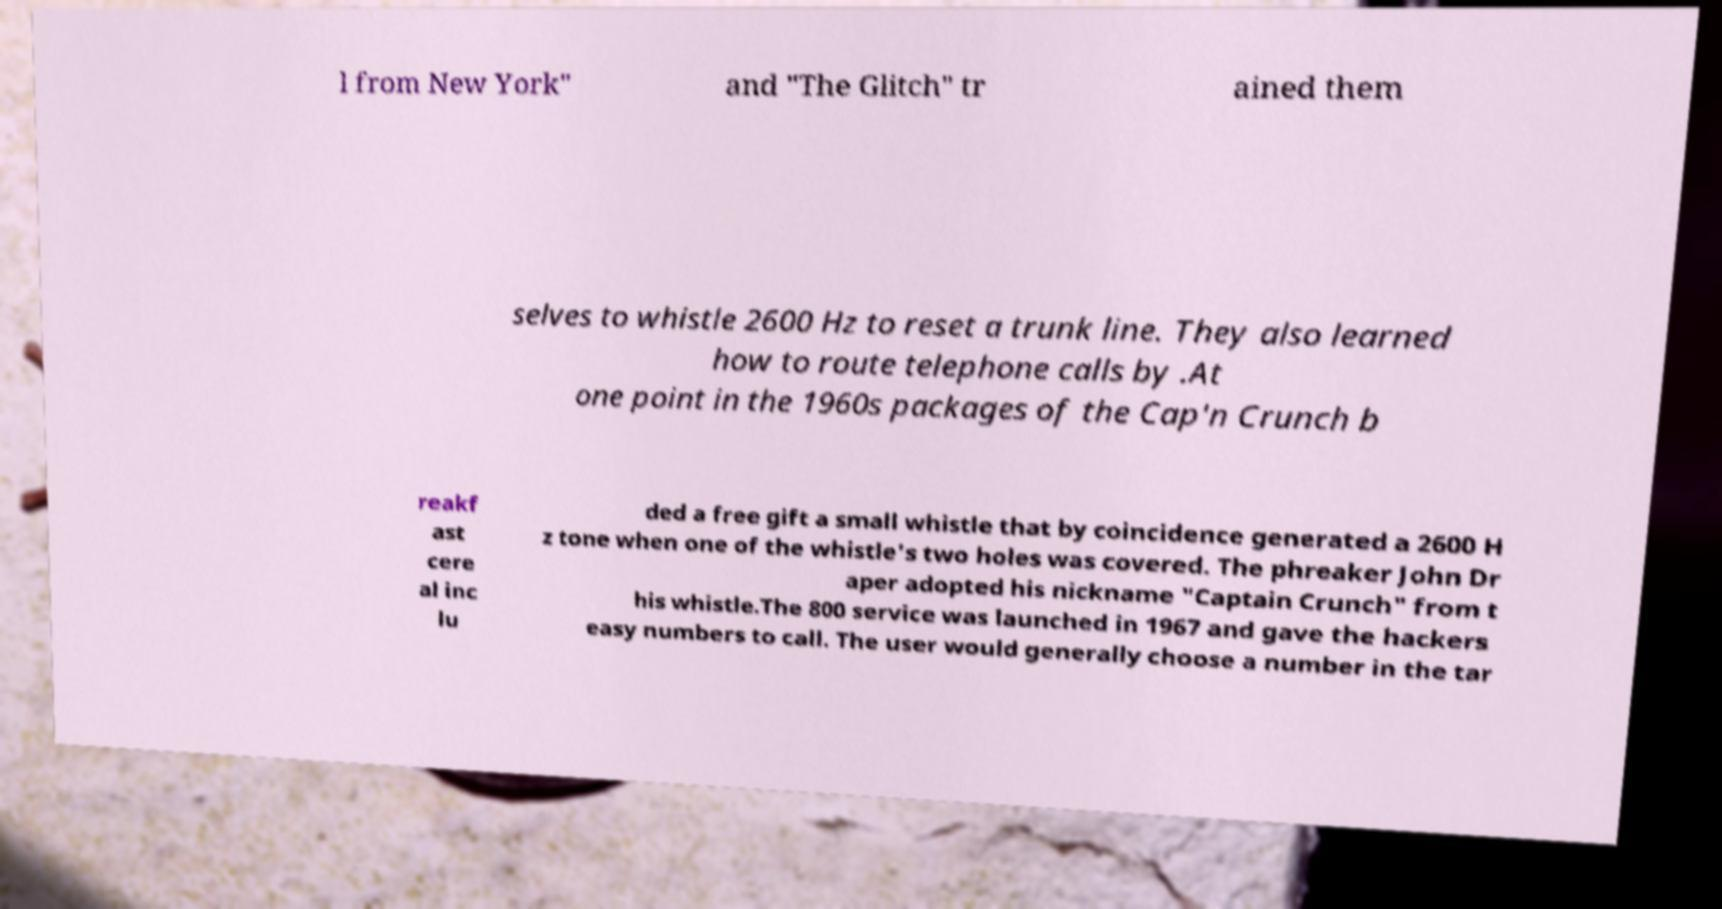What messages or text are displayed in this image? I need them in a readable, typed format. l from New York" and "The Glitch" tr ained them selves to whistle 2600 Hz to reset a trunk line. They also learned how to route telephone calls by .At one point in the 1960s packages of the Cap'n Crunch b reakf ast cere al inc lu ded a free gift a small whistle that by coincidence generated a 2600 H z tone when one of the whistle's two holes was covered. The phreaker John Dr aper adopted his nickname "Captain Crunch" from t his whistle.The 800 service was launched in 1967 and gave the hackers easy numbers to call. The user would generally choose a number in the tar 